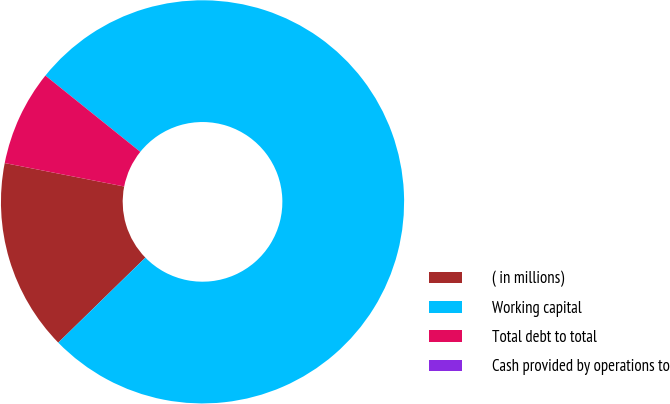<chart> <loc_0><loc_0><loc_500><loc_500><pie_chart><fcel>( in millions)<fcel>Working capital<fcel>Total debt to total<fcel>Cash provided by operations to<nl><fcel>15.39%<fcel>76.92%<fcel>7.69%<fcel>0.0%<nl></chart> 